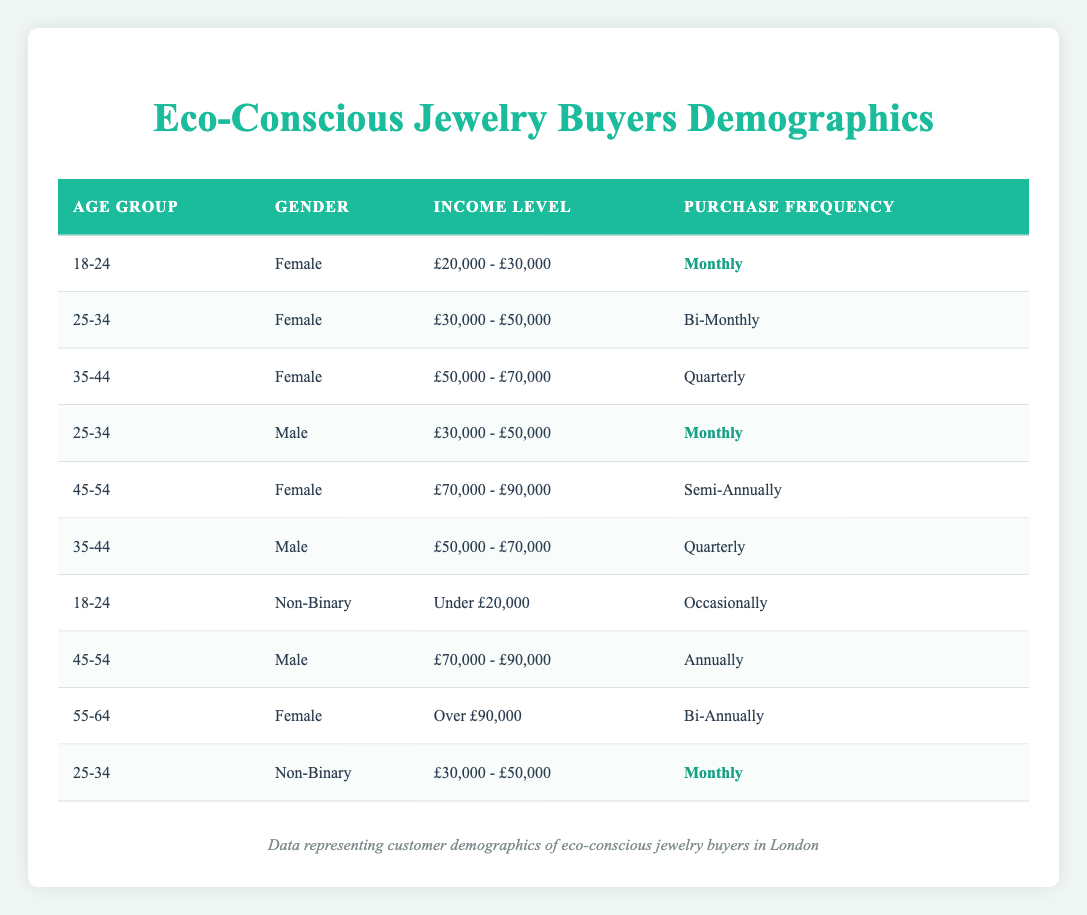What is the purchase frequency of male customers aged 25-34? The table shows that there is one entry for male customers in the 25-34 age group, which indicates a purchase frequency of "Monthly."
Answer: Monthly How many customers in the data are female? By counting the rows labeled "Female" in the gender column, we find there are four female customers in the table.
Answer: 4 Is it true that there are any customers who earn under £20,000? There is one entry in the table with the income level categorized as "Under £20,000" for a non-binary customer aged 18-24, confirming that this is true.
Answer: Yes What is the average income level of customers who purchase jewelry quarterly? Two customers purchase jewelry quarterly: one female aged 35-44 with an income between £50,000 and £70,000, and one male also aged 35-44 with the same income level. The average is calculated as ((50,000 + 70,000) / 2) = £60,000.
Answer: £60,000 How many customers have a purchase frequency of "Monthly"? The table has three entries with a purchase frequency of "Monthly": one female aged 18-24, one male aged 25-34, and one non-binary customer aged 25-34.
Answer: 3 What is the gender of customers who are aged 45-54? The table lists two customers aged 45-54: one is female with an income of £70,000 - £90,000, and the other is male with the same income level.
Answer: Both Male and Female How many customers aged 55-64 have a purchase frequency of "Bi-Annually"? There is one entry for a female customer aged 55-64 indicating a purchase frequency of "Bi-Annually," thus the answer is one.
Answer: 1 Is there a customer who has a purchase frequency of "Annually" in the age group of 45-54? The table shows one male customer aged 45-54 with a purchase frequency of "Annually," verifying that this is true.
Answer: Yes Which income level is most common among eco-conscious jewelry buyers based on the table? The income level of £30,000 - £50,000 appears three times in the data: two customers of this income level make monthly purchases and one bi-monthly. Thus, it's the most common income level.
Answer: £30,000 - £50,000 